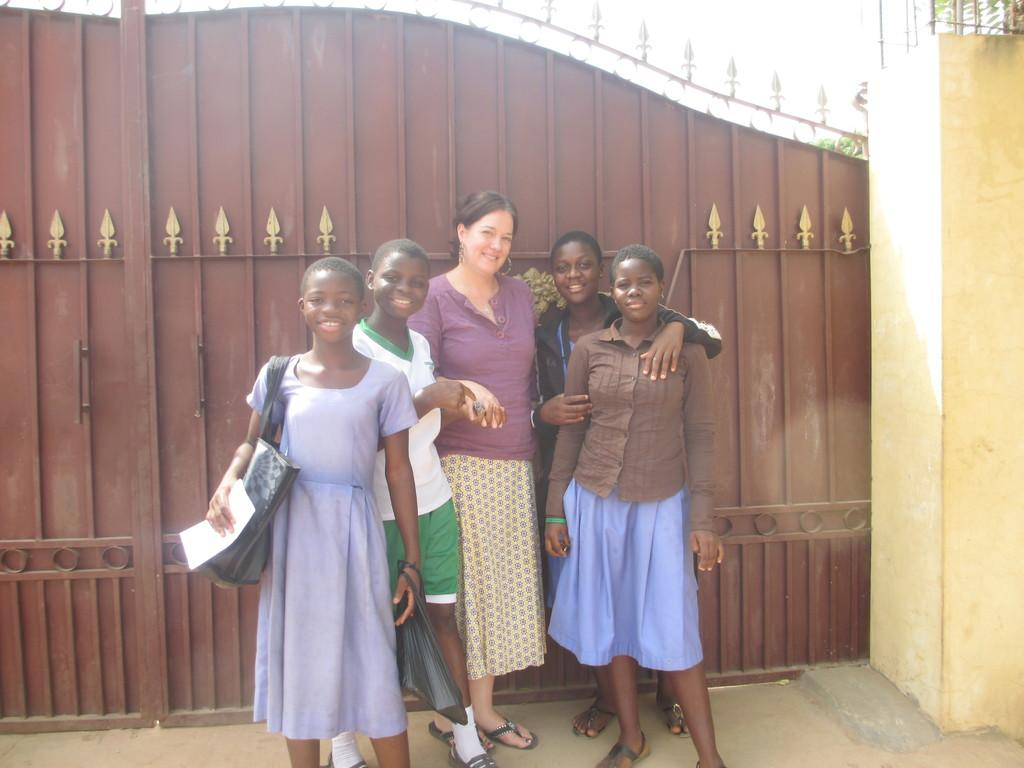What can be seen in the image? There are women standing in the image. Where are the women standing? The women are standing on the floor. What is visible in the background of the image? There is a gate in the background of the image. What type of drum is being played by the women in the image? There is no drum present in the image; the women are simply standing. 